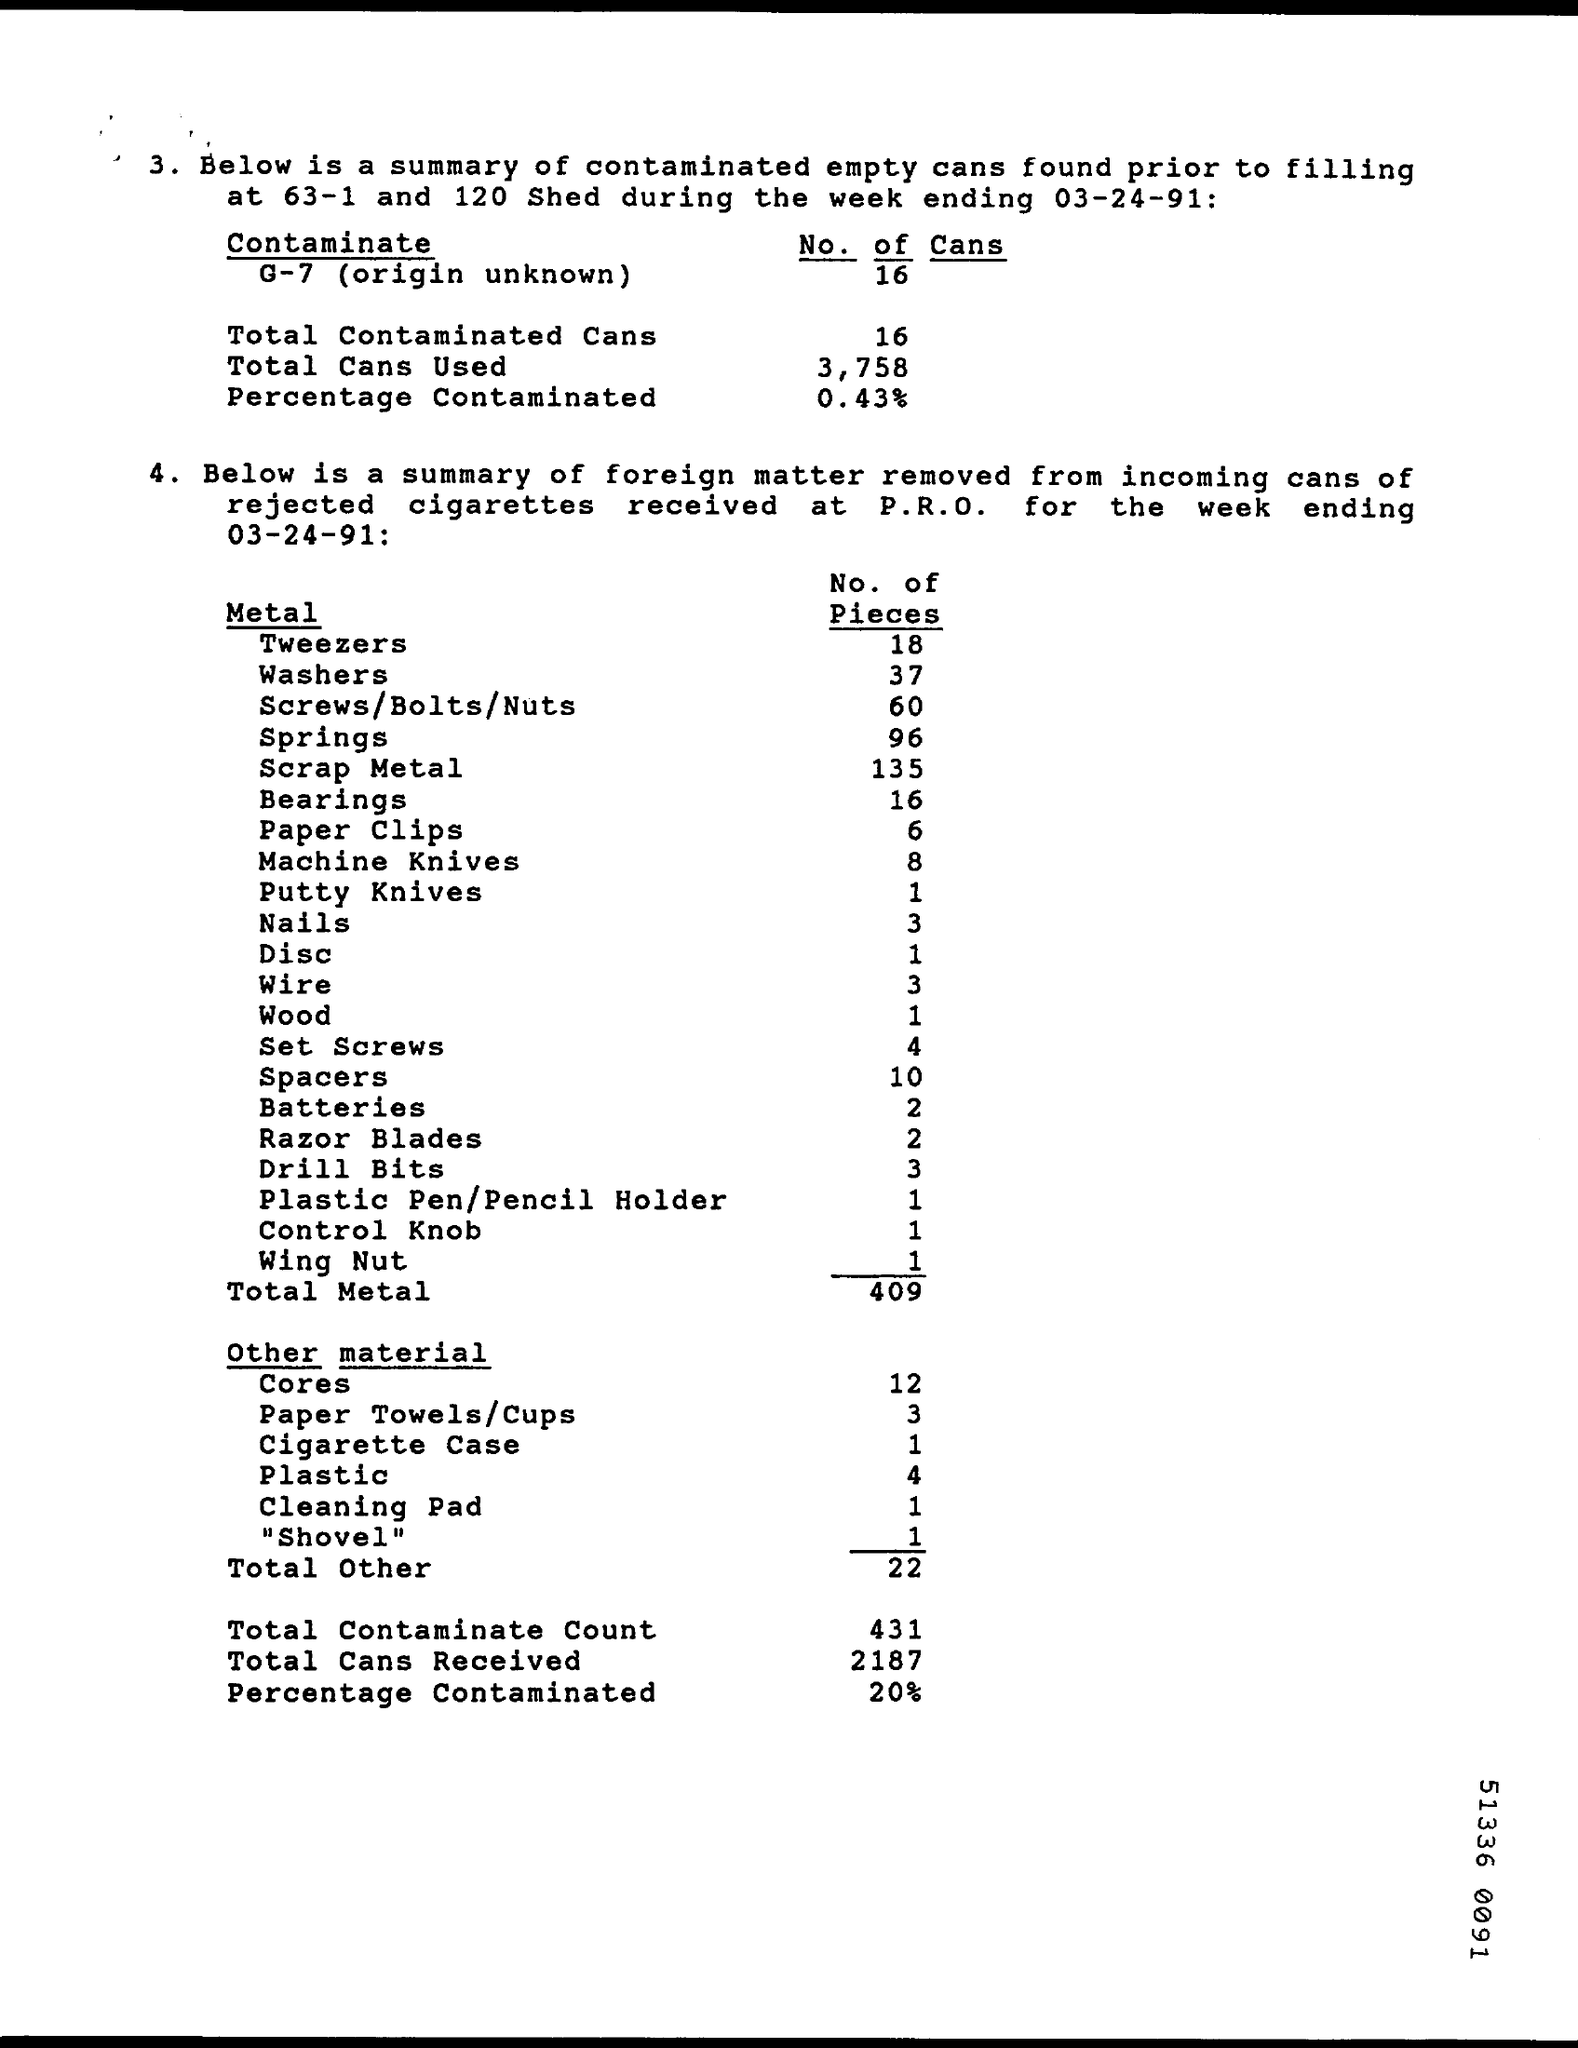Point out several critical features in this image. The total contaminant count is 431. Two pieces of batteries were found. 